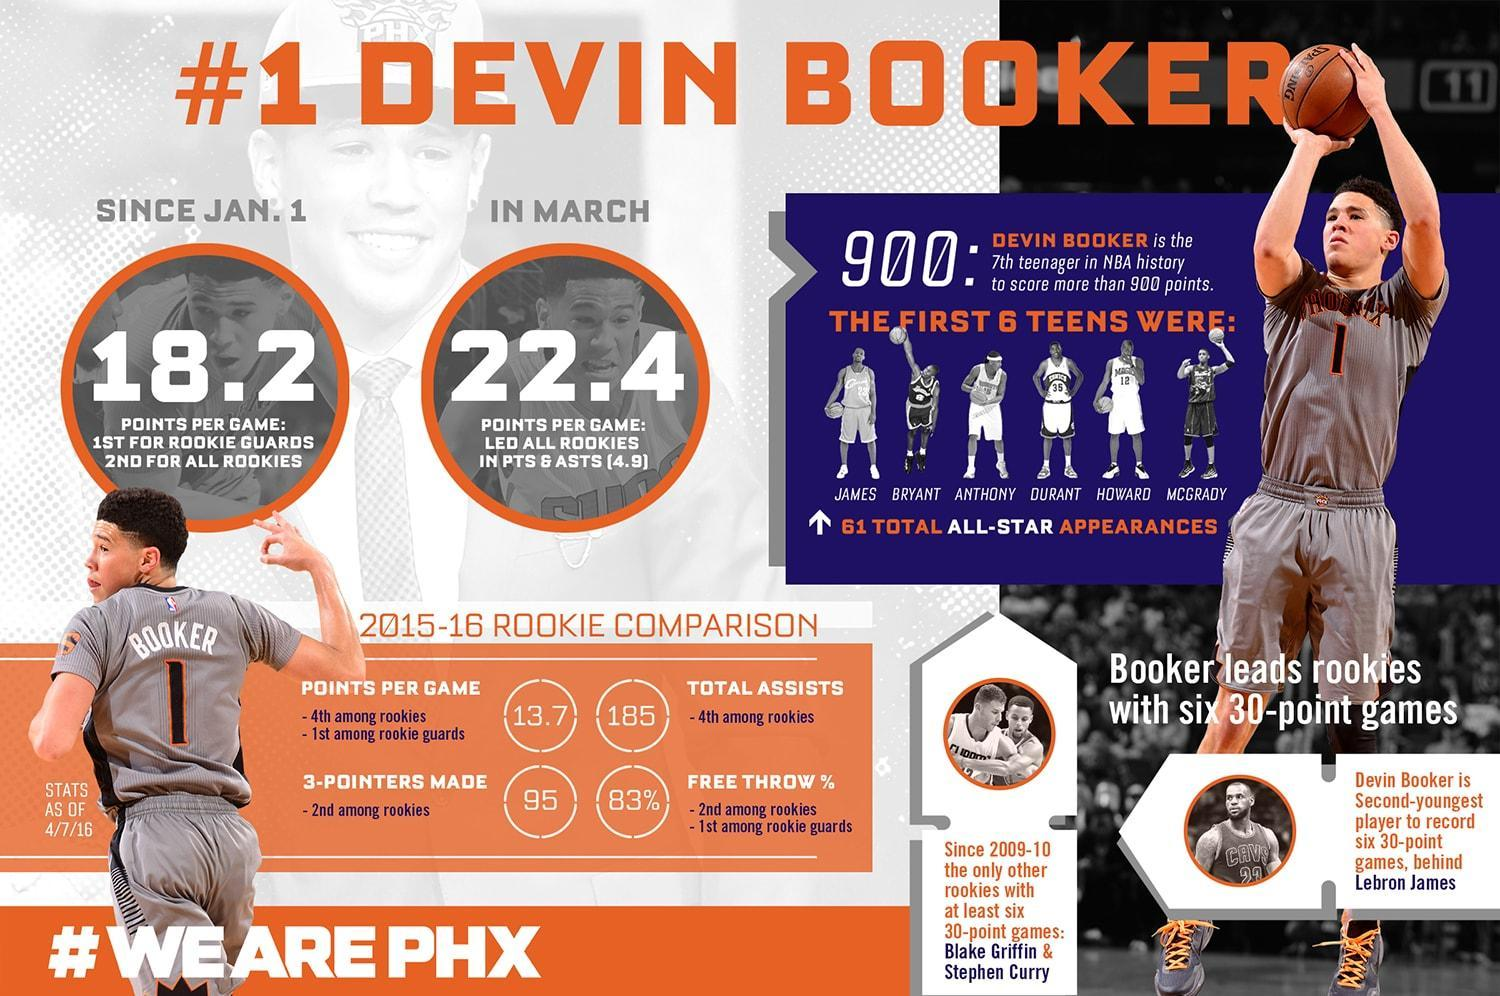Which player stood first among points per game among rookie guards and had the 2nd FT percentage among rookies?
Answer the question with a short phrase. Devin Booker Identify the player with jersey number 12 ? Howard Which team did Devin Booker Play for, Chicago Bulls, Phoenix Suns, Cleveland Cavaliers, or Los Angeles Lakers ? Phoenix Suns 